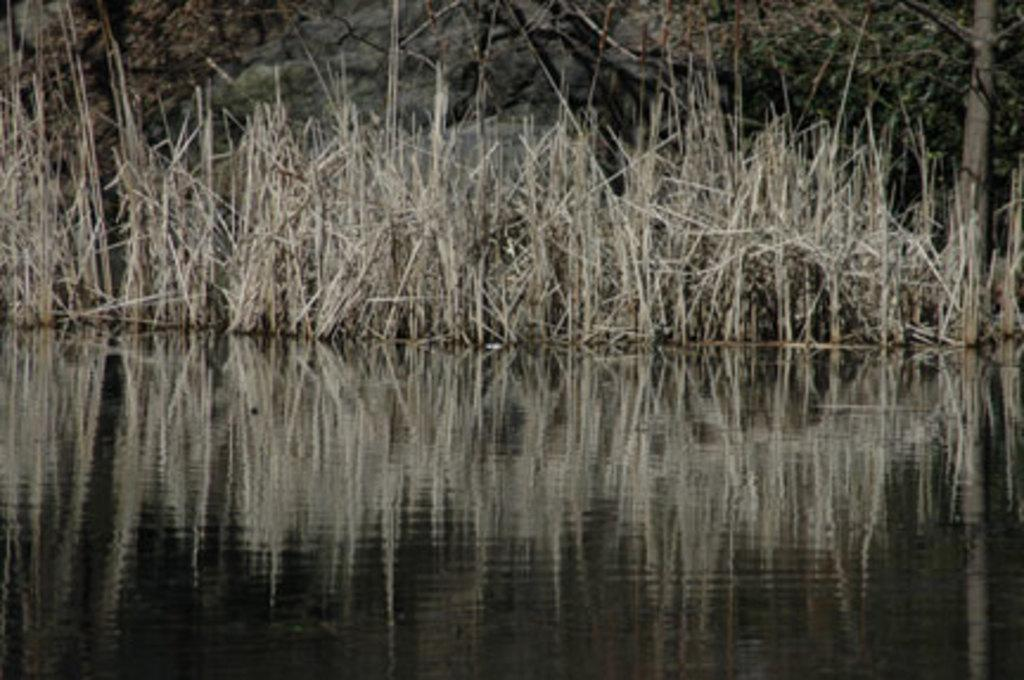Where was the picture taken? The picture was clicked outside. What can be seen in the foreground of the image? There is a water body in the foreground of the image. What type of vegetation is present in the center of the image? There is grass in the center of the image. What can be seen in the background of the image? There are trees in the background of the image. What shape is the head of the person in the image? There is no person present in the image, so it is not possible to determine the shape of their head. 